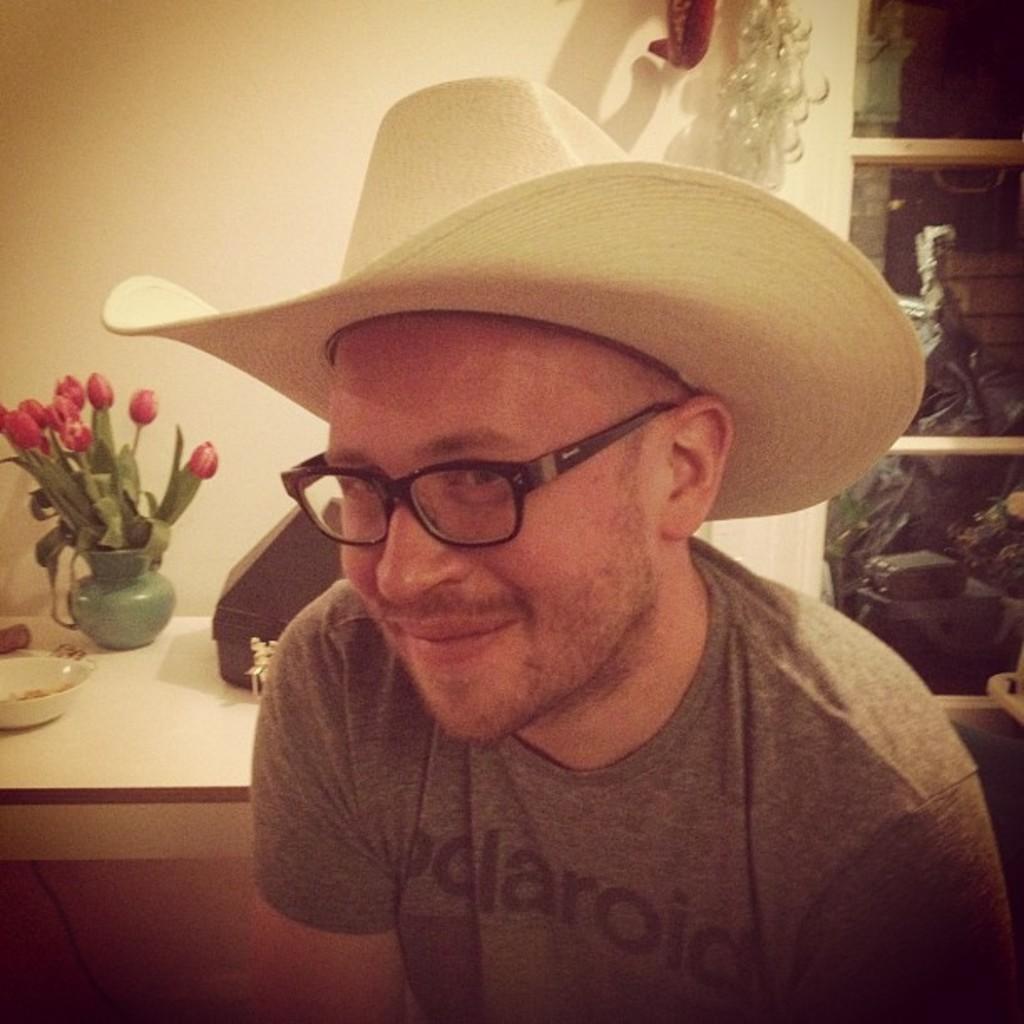Can you describe this image briefly? In this image, we can see a person is smiling and wearing a hat and glasses. Background we can see a table, wall and few objects. On top of the table, we can see a flower vase, bowl and few things. 